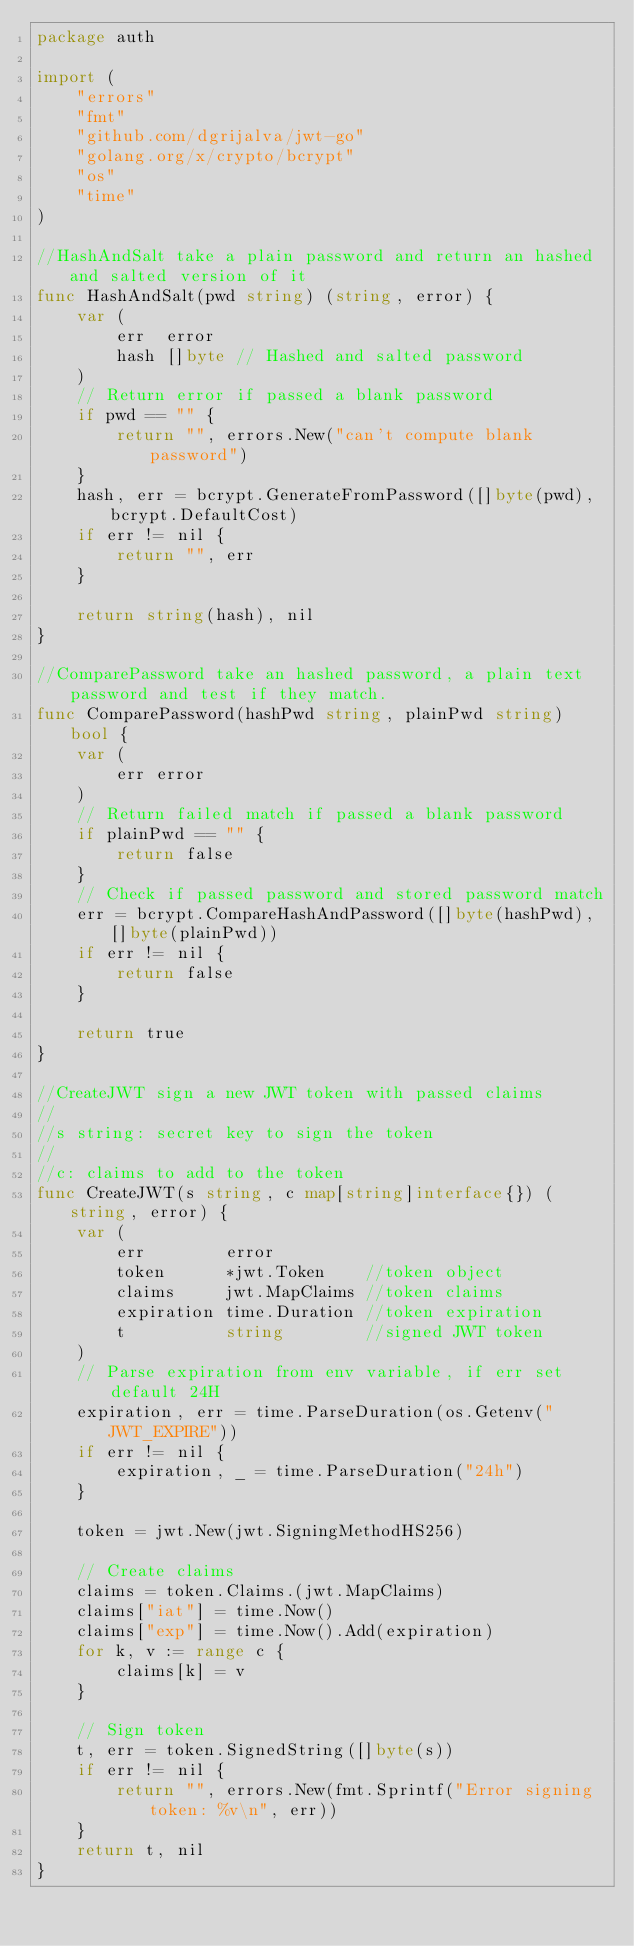Convert code to text. <code><loc_0><loc_0><loc_500><loc_500><_Go_>package auth

import (
	"errors"
	"fmt"
	"github.com/dgrijalva/jwt-go"
	"golang.org/x/crypto/bcrypt"
	"os"
	"time"
)

//HashAndSalt take a plain password and return an hashed and salted version of it
func HashAndSalt(pwd string) (string, error) {
	var (
		err  error
		hash []byte // Hashed and salted password
	)
	// Return error if passed a blank password
	if pwd == "" {
		return "", errors.New("can't compute blank password")
	}
	hash, err = bcrypt.GenerateFromPassword([]byte(pwd), bcrypt.DefaultCost)
	if err != nil {
		return "", err
	}

	return string(hash), nil
}

//ComparePassword take an hashed password, a plain text password and test if they match.
func ComparePassword(hashPwd string, plainPwd string) bool {
	var (
		err error
	)
	// Return failed match if passed a blank password
	if plainPwd == "" {
		return false
	}
	// Check if passed password and stored password match
	err = bcrypt.CompareHashAndPassword([]byte(hashPwd), []byte(plainPwd))
	if err != nil {
		return false
	}

	return true
}

//CreateJWT sign a new JWT token with passed claims
//
//s string: secret key to sign the token
//
//c: claims to add to the token
func CreateJWT(s string, c map[string]interface{}) (string, error) {
	var (
		err        error
		token      *jwt.Token    //token object
		claims     jwt.MapClaims //token claims
		expiration time.Duration //token expiration
		t          string        //signed JWT token
	)
	// Parse expiration from env variable, if err set default 24H
	expiration, err = time.ParseDuration(os.Getenv("JWT_EXPIRE"))
	if err != nil {
		expiration, _ = time.ParseDuration("24h")
	}

	token = jwt.New(jwt.SigningMethodHS256)

	// Create claims
	claims = token.Claims.(jwt.MapClaims)
	claims["iat"] = time.Now()
	claims["exp"] = time.Now().Add(expiration)
	for k, v := range c {
		claims[k] = v
	}

	// Sign token
	t, err = token.SignedString([]byte(s))
	if err != nil {
		return "", errors.New(fmt.Sprintf("Error signing token: %v\n", err))
	}
	return t, nil
}
</code> 